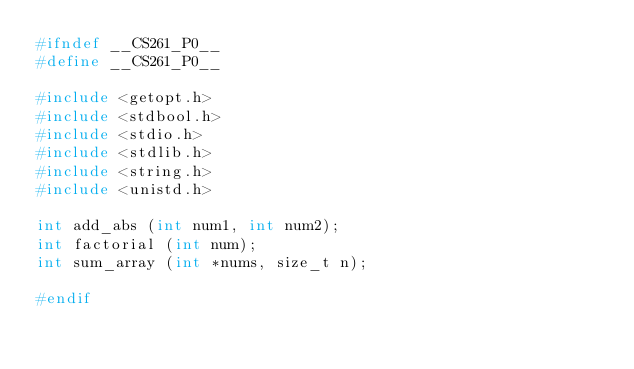Convert code to text. <code><loc_0><loc_0><loc_500><loc_500><_C_>#ifndef __CS261_P0__
#define __CS261_P0__

#include <getopt.h>
#include <stdbool.h>
#include <stdio.h>
#include <stdlib.h>
#include <string.h>
#include <unistd.h>

int add_abs (int num1, int num2);
int factorial (int num);
int sum_array (int *nums, size_t n);

#endif
</code> 